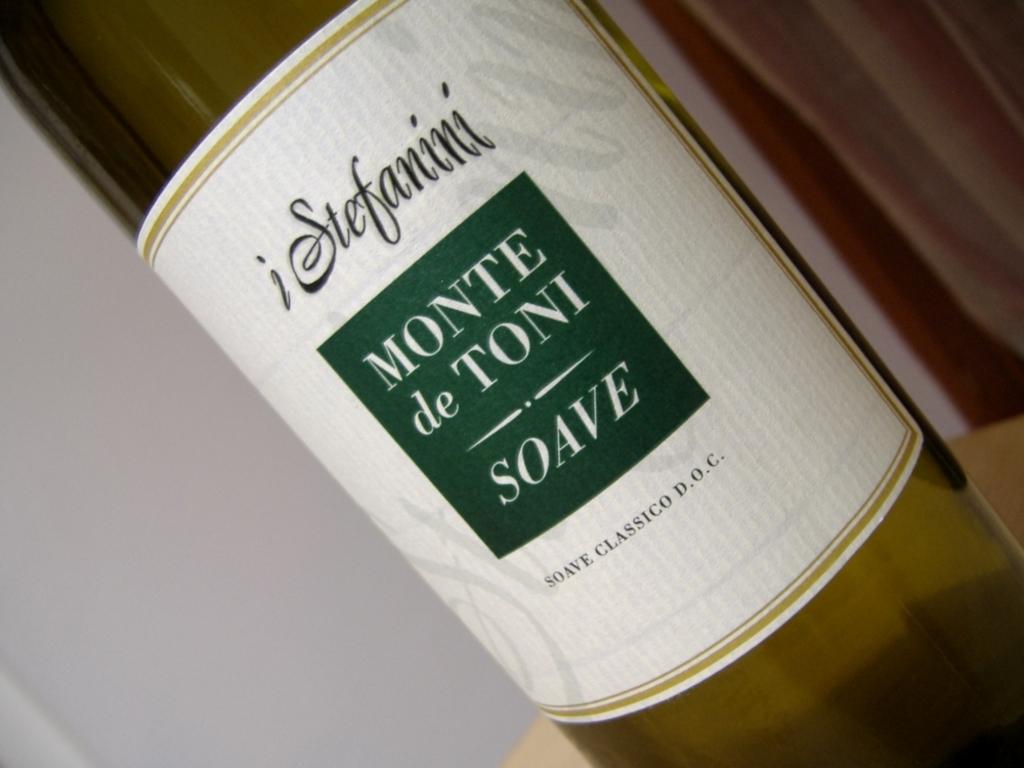What brand of wine is that?
Your answer should be very brief. I stefanini. What type of wine is this?
Give a very brief answer. Soave. 